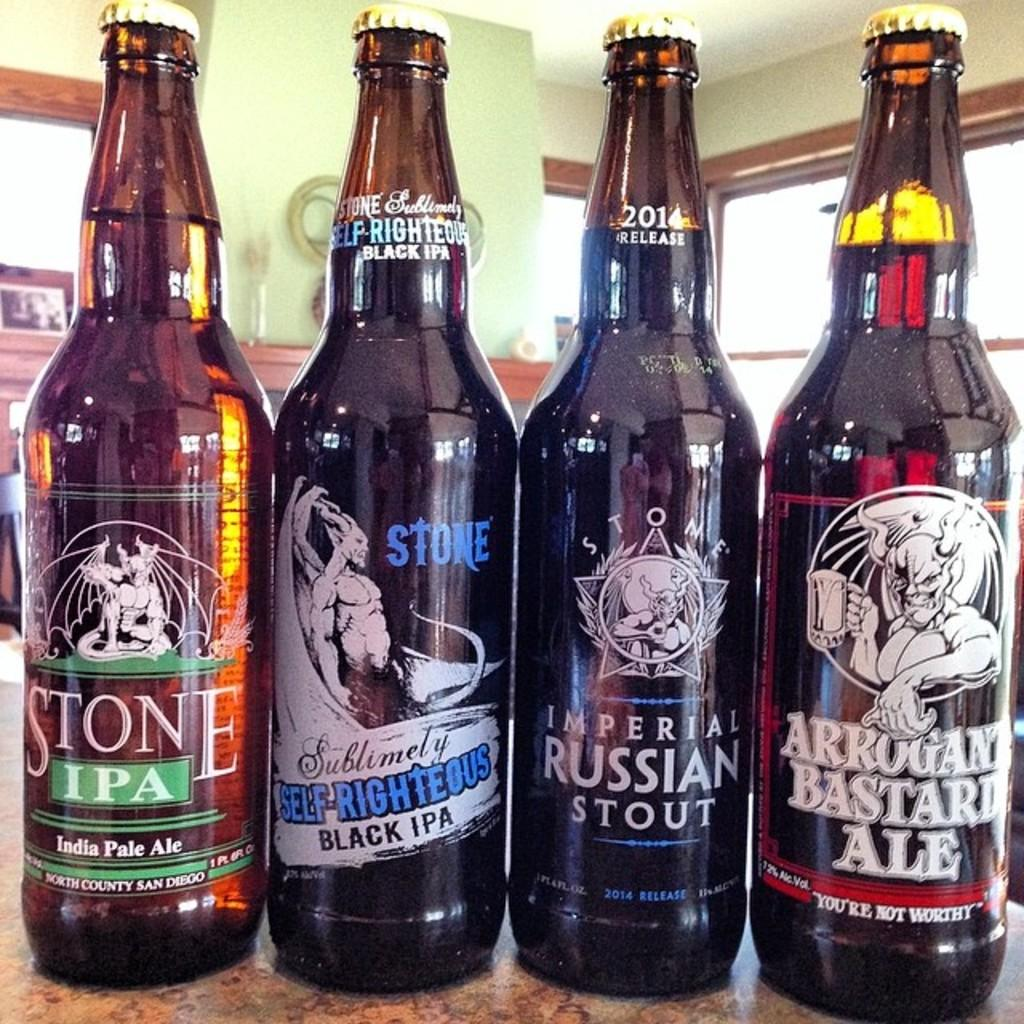How many bottles are on the table in the image? There are four bottles on the table in the image. What can be seen in the background of the image? There is a wall and a glass window in the background of the image. Are there any objects visible in the background? Yes, there are objects visible in the background of the image. How many ghosts can be seen interacting with the bottles in the image? There are no ghosts present in the image; it only features bottles on a table and a background with a wall and glass window. What type of tongue is visible on the wall in the image? There is no tongue visible on the wall or anywhere else in the image. 